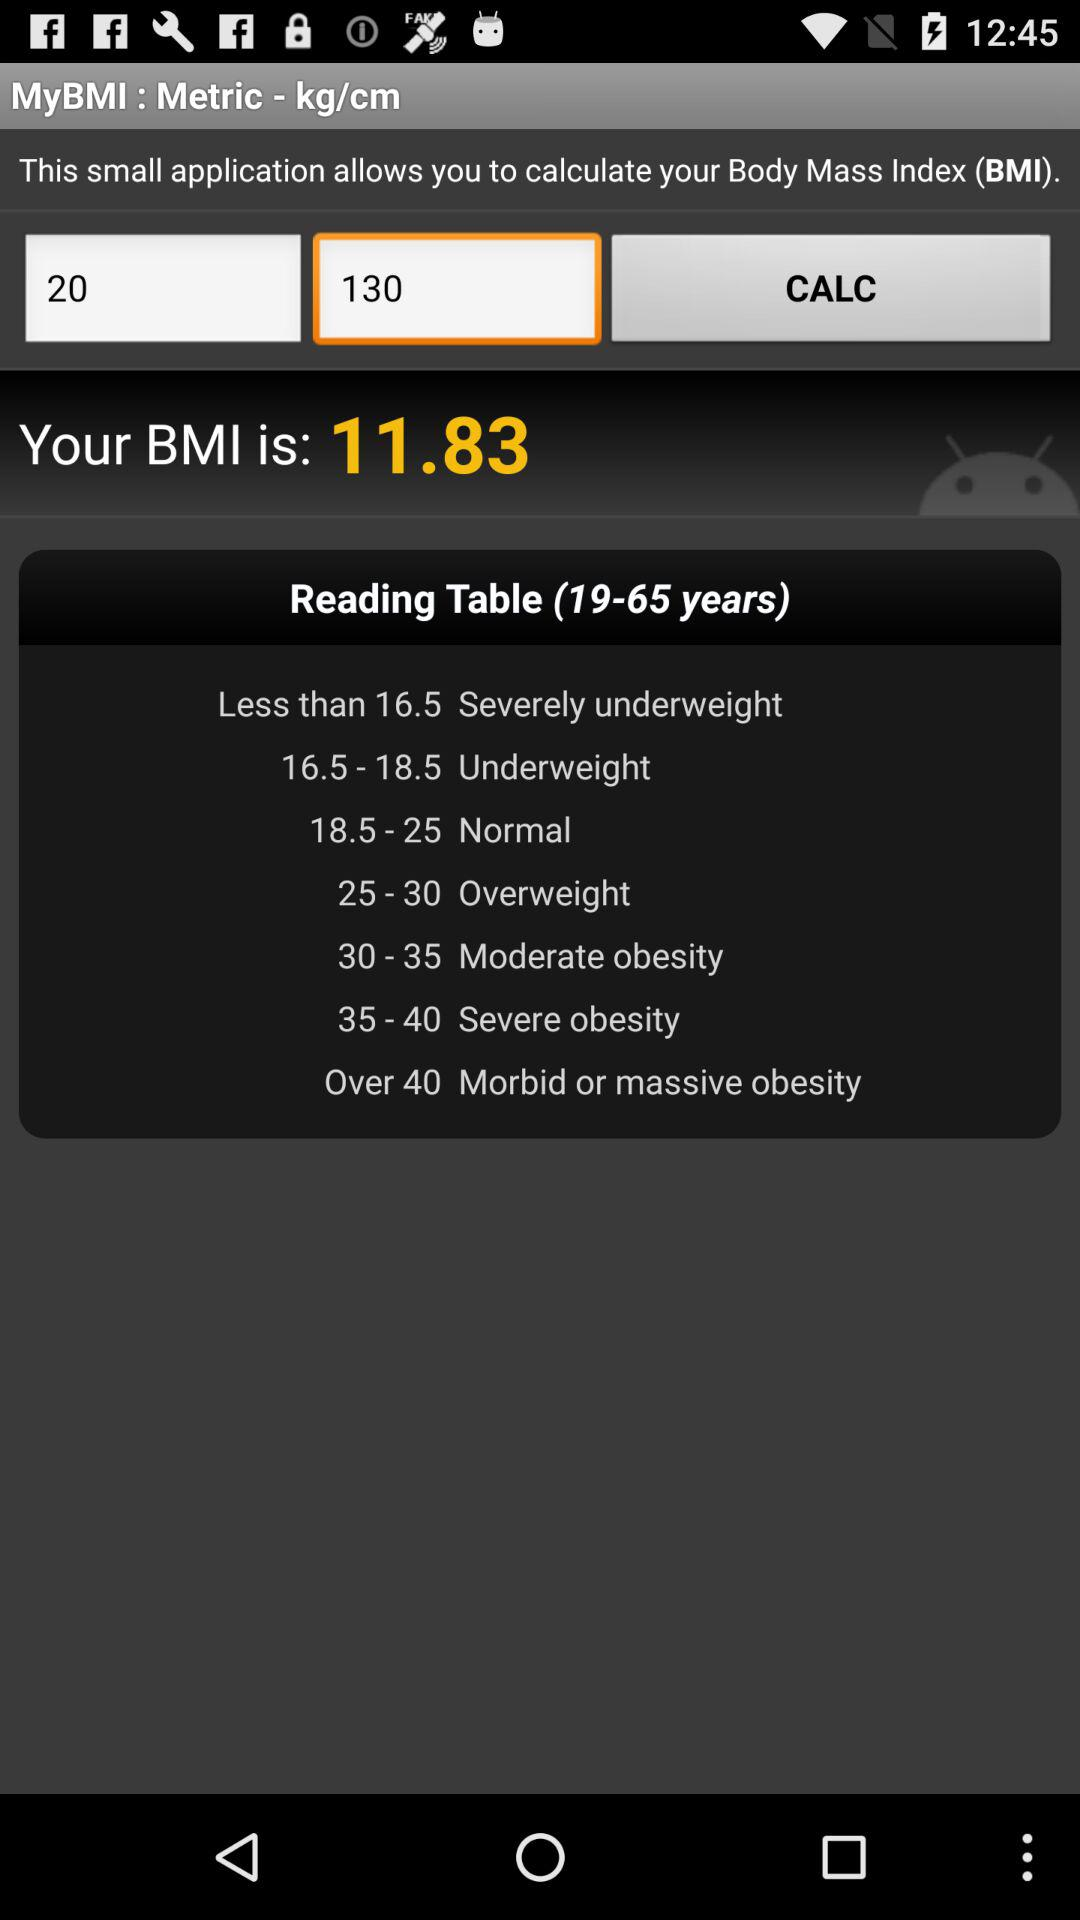What is the BMI value? The BMI value is 11.83. 